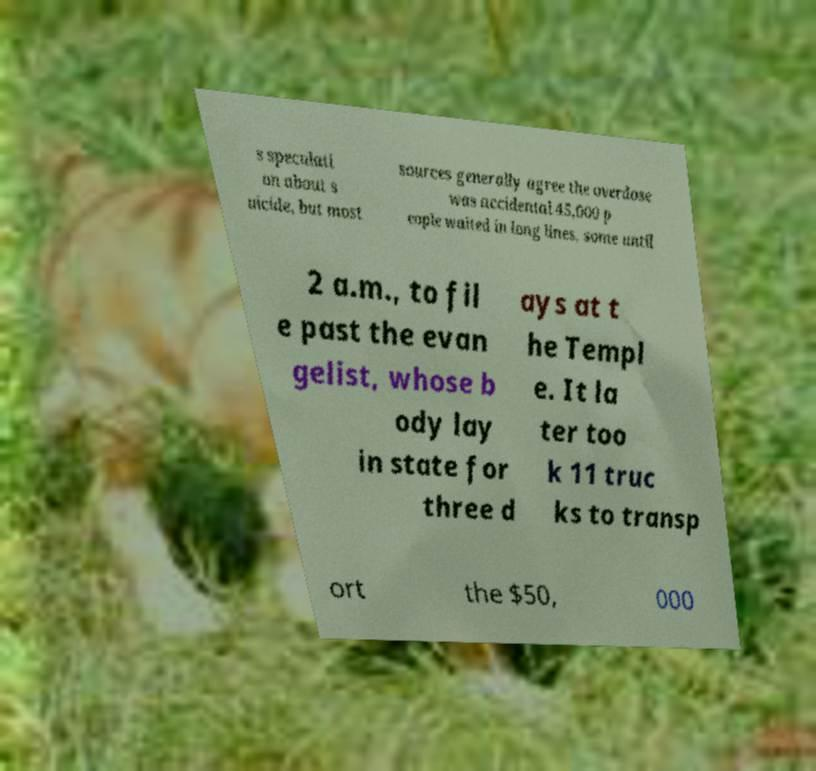Can you read and provide the text displayed in the image?This photo seems to have some interesting text. Can you extract and type it out for me? s speculati on about s uicide, but most sources generally agree the overdose was accidental.45,000 p eople waited in long lines, some until 2 a.m., to fil e past the evan gelist, whose b ody lay in state for three d ays at t he Templ e. It la ter too k 11 truc ks to transp ort the $50, 000 